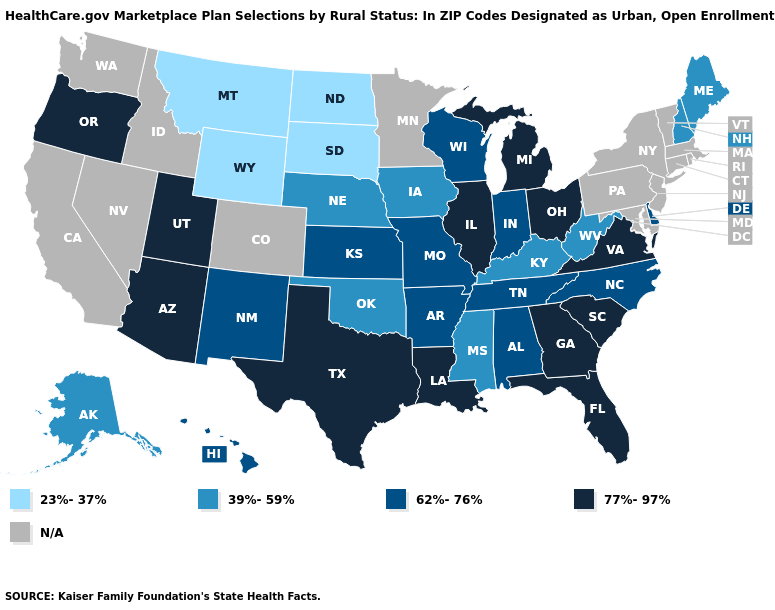What is the highest value in the West ?
Answer briefly. 77%-97%. Name the states that have a value in the range 39%-59%?
Keep it brief. Alaska, Iowa, Kentucky, Maine, Mississippi, Nebraska, New Hampshire, Oklahoma, West Virginia. What is the value of South Carolina?
Write a very short answer. 77%-97%. What is the lowest value in the USA?
Keep it brief. 23%-37%. Does the map have missing data?
Concise answer only. Yes. Which states have the lowest value in the South?
Short answer required. Kentucky, Mississippi, Oklahoma, West Virginia. Does Indiana have the highest value in the USA?
Answer briefly. No. Does South Carolina have the lowest value in the USA?
Concise answer only. No. What is the value of Arizona?
Short answer required. 77%-97%. Is the legend a continuous bar?
Write a very short answer. No. Does the map have missing data?
Answer briefly. Yes. Name the states that have a value in the range 77%-97%?
Be succinct. Arizona, Florida, Georgia, Illinois, Louisiana, Michigan, Ohio, Oregon, South Carolina, Texas, Utah, Virginia. What is the value of Oklahoma?
Keep it brief. 39%-59%. 